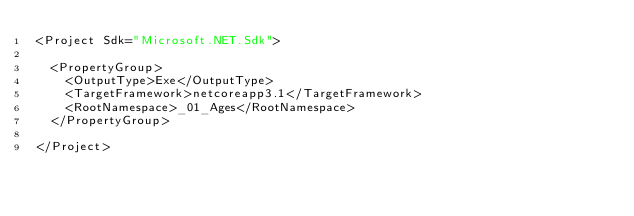<code> <loc_0><loc_0><loc_500><loc_500><_XML_><Project Sdk="Microsoft.NET.Sdk">

  <PropertyGroup>
    <OutputType>Exe</OutputType>
    <TargetFramework>netcoreapp3.1</TargetFramework>
    <RootNamespace>_01_Ages</RootNamespace>
  </PropertyGroup>

</Project>
</code> 